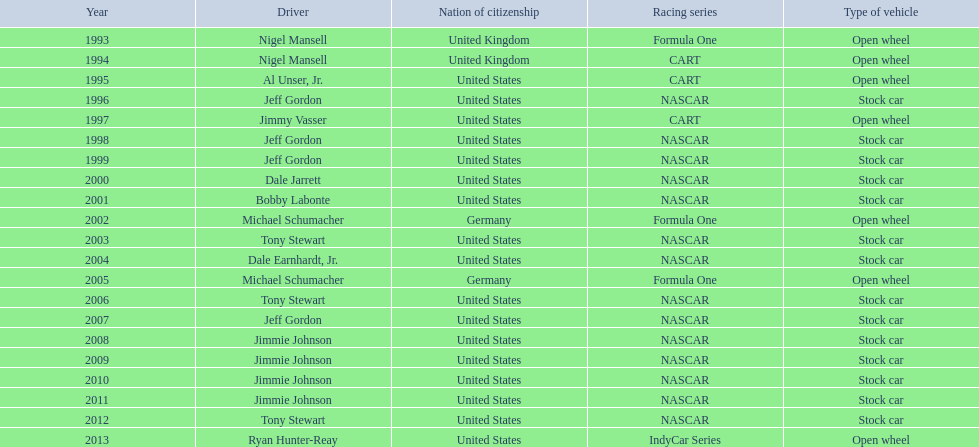What year(s) did nigel mansel receive epsy awards? 1993, 1994. What year(s) did michael schumacher receive epsy awards? 2002, 2005. What year(s) did jeff gordon receive epsy awards? 1996, 1998, 1999, 2007. What year(s) did al unser jr. receive epsy awards? 1995. Which driver only received one epsy award? Al Unser, Jr. 